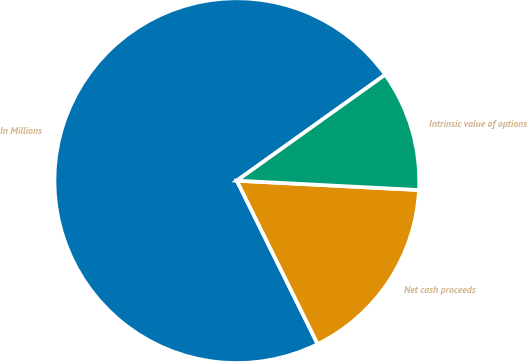<chart> <loc_0><loc_0><loc_500><loc_500><pie_chart><fcel>In Millions<fcel>Net cash proceeds<fcel>Intrinsic value of options<nl><fcel>72.44%<fcel>16.87%<fcel>10.69%<nl></chart> 